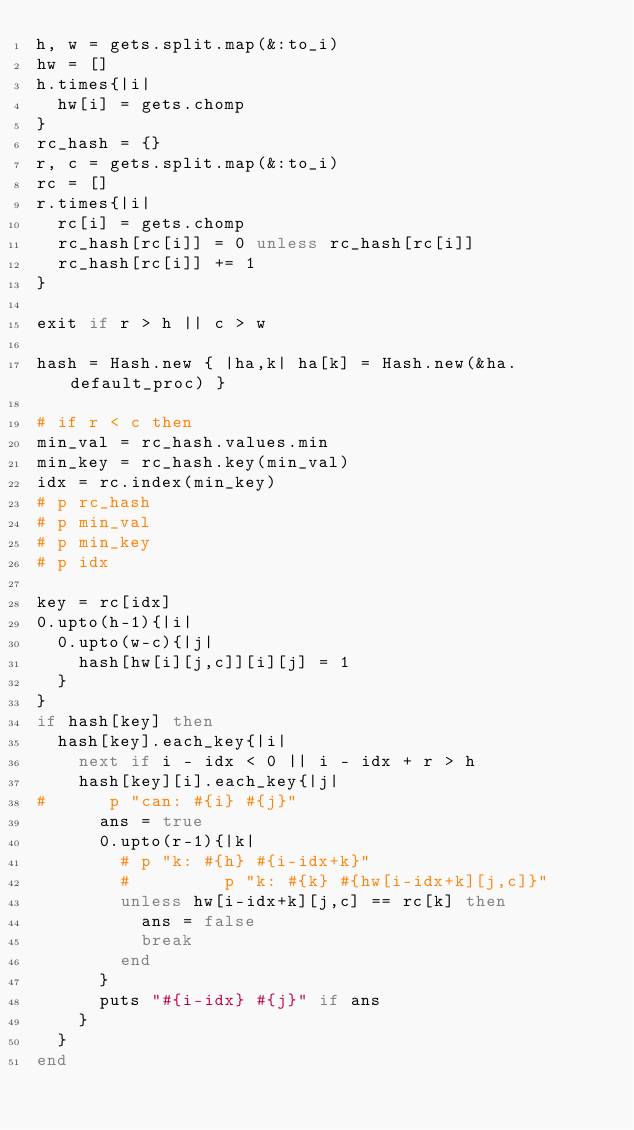Convert code to text. <code><loc_0><loc_0><loc_500><loc_500><_Ruby_>h, w = gets.split.map(&:to_i)
hw = []
h.times{|i|
  hw[i] = gets.chomp
}
rc_hash = {}
r, c = gets.split.map(&:to_i)
rc = []
r.times{|i|
  rc[i] = gets.chomp
  rc_hash[rc[i]] = 0 unless rc_hash[rc[i]]
  rc_hash[rc[i]] += 1
}

exit if r > h || c > w

hash = Hash.new { |ha,k| ha[k] = Hash.new(&ha.default_proc) }

# if r < c then
min_val = rc_hash.values.min
min_key = rc_hash.key(min_val)
idx = rc.index(min_key)
# p rc_hash
# p min_val
# p min_key
# p idx

key = rc[idx]
0.upto(h-1){|i|
  0.upto(w-c){|j|
    hash[hw[i][j,c]][i][j] = 1
  }
}
if hash[key] then
  hash[key].each_key{|i|
    next if i - idx < 0 || i - idx + r > h
    hash[key][i].each_key{|j|
#      p "can: #{i} #{j}"
      ans = true
      0.upto(r-1){|k|
        # p "k: #{h} #{i-idx+k}"
        #         p "k: #{k} #{hw[i-idx+k][j,c]}"
        unless hw[i-idx+k][j,c] == rc[k] then
          ans = false
          break
        end
      }
      puts "#{i-idx} #{j}" if ans
    }
  }
end</code> 